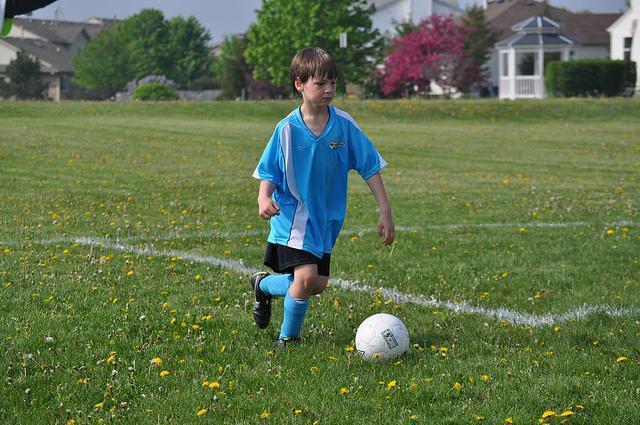How many chairs are seen?
Give a very brief answer. 0. 